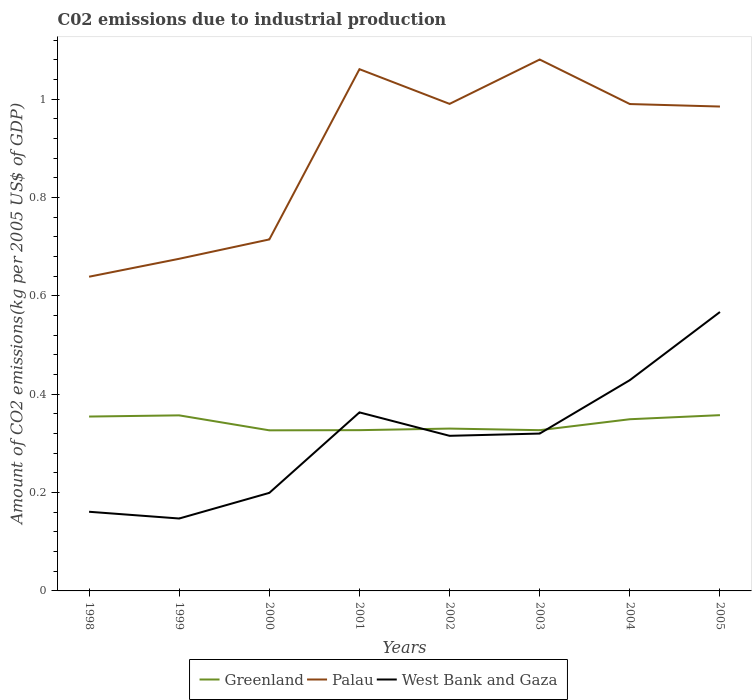Does the line corresponding to West Bank and Gaza intersect with the line corresponding to Palau?
Your response must be concise. No. Is the number of lines equal to the number of legend labels?
Keep it short and to the point. Yes. Across all years, what is the maximum amount of CO2 emitted due to industrial production in West Bank and Gaza?
Make the answer very short. 0.15. In which year was the amount of CO2 emitted due to industrial production in Greenland maximum?
Offer a very short reply. 2000. What is the total amount of CO2 emitted due to industrial production in West Bank and Gaza in the graph?
Provide a short and direct response. -0. What is the difference between the highest and the second highest amount of CO2 emitted due to industrial production in Palau?
Give a very brief answer. 0.44. How many years are there in the graph?
Provide a short and direct response. 8. Does the graph contain any zero values?
Your response must be concise. No. Does the graph contain grids?
Give a very brief answer. No. Where does the legend appear in the graph?
Ensure brevity in your answer.  Bottom center. What is the title of the graph?
Your answer should be very brief. C02 emissions due to industrial production. What is the label or title of the X-axis?
Keep it short and to the point. Years. What is the label or title of the Y-axis?
Provide a succinct answer. Amount of CO2 emissions(kg per 2005 US$ of GDP). What is the Amount of CO2 emissions(kg per 2005 US$ of GDP) of Greenland in 1998?
Make the answer very short. 0.35. What is the Amount of CO2 emissions(kg per 2005 US$ of GDP) in Palau in 1998?
Your answer should be compact. 0.64. What is the Amount of CO2 emissions(kg per 2005 US$ of GDP) in West Bank and Gaza in 1998?
Make the answer very short. 0.16. What is the Amount of CO2 emissions(kg per 2005 US$ of GDP) in Greenland in 1999?
Make the answer very short. 0.36. What is the Amount of CO2 emissions(kg per 2005 US$ of GDP) in Palau in 1999?
Offer a terse response. 0.68. What is the Amount of CO2 emissions(kg per 2005 US$ of GDP) in West Bank and Gaza in 1999?
Your answer should be very brief. 0.15. What is the Amount of CO2 emissions(kg per 2005 US$ of GDP) in Greenland in 2000?
Keep it short and to the point. 0.33. What is the Amount of CO2 emissions(kg per 2005 US$ of GDP) of Palau in 2000?
Provide a succinct answer. 0.71. What is the Amount of CO2 emissions(kg per 2005 US$ of GDP) of West Bank and Gaza in 2000?
Your answer should be very brief. 0.2. What is the Amount of CO2 emissions(kg per 2005 US$ of GDP) in Greenland in 2001?
Your answer should be very brief. 0.33. What is the Amount of CO2 emissions(kg per 2005 US$ of GDP) in Palau in 2001?
Your answer should be compact. 1.06. What is the Amount of CO2 emissions(kg per 2005 US$ of GDP) of West Bank and Gaza in 2001?
Offer a very short reply. 0.36. What is the Amount of CO2 emissions(kg per 2005 US$ of GDP) of Greenland in 2002?
Make the answer very short. 0.33. What is the Amount of CO2 emissions(kg per 2005 US$ of GDP) in Palau in 2002?
Give a very brief answer. 0.99. What is the Amount of CO2 emissions(kg per 2005 US$ of GDP) of West Bank and Gaza in 2002?
Ensure brevity in your answer.  0.32. What is the Amount of CO2 emissions(kg per 2005 US$ of GDP) in Greenland in 2003?
Your answer should be compact. 0.33. What is the Amount of CO2 emissions(kg per 2005 US$ of GDP) in Palau in 2003?
Give a very brief answer. 1.08. What is the Amount of CO2 emissions(kg per 2005 US$ of GDP) in West Bank and Gaza in 2003?
Your response must be concise. 0.32. What is the Amount of CO2 emissions(kg per 2005 US$ of GDP) of Greenland in 2004?
Your response must be concise. 0.35. What is the Amount of CO2 emissions(kg per 2005 US$ of GDP) of Palau in 2004?
Keep it short and to the point. 0.99. What is the Amount of CO2 emissions(kg per 2005 US$ of GDP) of West Bank and Gaza in 2004?
Offer a terse response. 0.43. What is the Amount of CO2 emissions(kg per 2005 US$ of GDP) in Greenland in 2005?
Your answer should be very brief. 0.36. What is the Amount of CO2 emissions(kg per 2005 US$ of GDP) of Palau in 2005?
Offer a very short reply. 0.99. What is the Amount of CO2 emissions(kg per 2005 US$ of GDP) in West Bank and Gaza in 2005?
Give a very brief answer. 0.57. Across all years, what is the maximum Amount of CO2 emissions(kg per 2005 US$ of GDP) of Greenland?
Ensure brevity in your answer.  0.36. Across all years, what is the maximum Amount of CO2 emissions(kg per 2005 US$ of GDP) of Palau?
Make the answer very short. 1.08. Across all years, what is the maximum Amount of CO2 emissions(kg per 2005 US$ of GDP) in West Bank and Gaza?
Provide a short and direct response. 0.57. Across all years, what is the minimum Amount of CO2 emissions(kg per 2005 US$ of GDP) in Greenland?
Give a very brief answer. 0.33. Across all years, what is the minimum Amount of CO2 emissions(kg per 2005 US$ of GDP) of Palau?
Keep it short and to the point. 0.64. Across all years, what is the minimum Amount of CO2 emissions(kg per 2005 US$ of GDP) in West Bank and Gaza?
Provide a short and direct response. 0.15. What is the total Amount of CO2 emissions(kg per 2005 US$ of GDP) of Greenland in the graph?
Offer a terse response. 2.73. What is the total Amount of CO2 emissions(kg per 2005 US$ of GDP) in Palau in the graph?
Provide a short and direct response. 7.14. What is the total Amount of CO2 emissions(kg per 2005 US$ of GDP) of West Bank and Gaza in the graph?
Ensure brevity in your answer.  2.5. What is the difference between the Amount of CO2 emissions(kg per 2005 US$ of GDP) in Greenland in 1998 and that in 1999?
Make the answer very short. -0. What is the difference between the Amount of CO2 emissions(kg per 2005 US$ of GDP) in Palau in 1998 and that in 1999?
Offer a terse response. -0.04. What is the difference between the Amount of CO2 emissions(kg per 2005 US$ of GDP) in West Bank and Gaza in 1998 and that in 1999?
Your response must be concise. 0.01. What is the difference between the Amount of CO2 emissions(kg per 2005 US$ of GDP) of Greenland in 1998 and that in 2000?
Your answer should be very brief. 0.03. What is the difference between the Amount of CO2 emissions(kg per 2005 US$ of GDP) in Palau in 1998 and that in 2000?
Offer a very short reply. -0.08. What is the difference between the Amount of CO2 emissions(kg per 2005 US$ of GDP) in West Bank and Gaza in 1998 and that in 2000?
Your response must be concise. -0.04. What is the difference between the Amount of CO2 emissions(kg per 2005 US$ of GDP) of Greenland in 1998 and that in 2001?
Offer a terse response. 0.03. What is the difference between the Amount of CO2 emissions(kg per 2005 US$ of GDP) in Palau in 1998 and that in 2001?
Provide a short and direct response. -0.42. What is the difference between the Amount of CO2 emissions(kg per 2005 US$ of GDP) of West Bank and Gaza in 1998 and that in 2001?
Ensure brevity in your answer.  -0.2. What is the difference between the Amount of CO2 emissions(kg per 2005 US$ of GDP) of Greenland in 1998 and that in 2002?
Offer a very short reply. 0.02. What is the difference between the Amount of CO2 emissions(kg per 2005 US$ of GDP) in Palau in 1998 and that in 2002?
Your answer should be very brief. -0.35. What is the difference between the Amount of CO2 emissions(kg per 2005 US$ of GDP) in West Bank and Gaza in 1998 and that in 2002?
Provide a short and direct response. -0.15. What is the difference between the Amount of CO2 emissions(kg per 2005 US$ of GDP) in Greenland in 1998 and that in 2003?
Your response must be concise. 0.03. What is the difference between the Amount of CO2 emissions(kg per 2005 US$ of GDP) in Palau in 1998 and that in 2003?
Your answer should be very brief. -0.44. What is the difference between the Amount of CO2 emissions(kg per 2005 US$ of GDP) of West Bank and Gaza in 1998 and that in 2003?
Offer a very short reply. -0.16. What is the difference between the Amount of CO2 emissions(kg per 2005 US$ of GDP) in Greenland in 1998 and that in 2004?
Offer a very short reply. 0.01. What is the difference between the Amount of CO2 emissions(kg per 2005 US$ of GDP) of Palau in 1998 and that in 2004?
Offer a terse response. -0.35. What is the difference between the Amount of CO2 emissions(kg per 2005 US$ of GDP) in West Bank and Gaza in 1998 and that in 2004?
Your answer should be very brief. -0.27. What is the difference between the Amount of CO2 emissions(kg per 2005 US$ of GDP) in Greenland in 1998 and that in 2005?
Provide a succinct answer. -0. What is the difference between the Amount of CO2 emissions(kg per 2005 US$ of GDP) of Palau in 1998 and that in 2005?
Provide a succinct answer. -0.35. What is the difference between the Amount of CO2 emissions(kg per 2005 US$ of GDP) in West Bank and Gaza in 1998 and that in 2005?
Keep it short and to the point. -0.41. What is the difference between the Amount of CO2 emissions(kg per 2005 US$ of GDP) of Greenland in 1999 and that in 2000?
Give a very brief answer. 0.03. What is the difference between the Amount of CO2 emissions(kg per 2005 US$ of GDP) in Palau in 1999 and that in 2000?
Your answer should be very brief. -0.04. What is the difference between the Amount of CO2 emissions(kg per 2005 US$ of GDP) in West Bank and Gaza in 1999 and that in 2000?
Offer a very short reply. -0.05. What is the difference between the Amount of CO2 emissions(kg per 2005 US$ of GDP) in Greenland in 1999 and that in 2001?
Ensure brevity in your answer.  0.03. What is the difference between the Amount of CO2 emissions(kg per 2005 US$ of GDP) in Palau in 1999 and that in 2001?
Your response must be concise. -0.39. What is the difference between the Amount of CO2 emissions(kg per 2005 US$ of GDP) in West Bank and Gaza in 1999 and that in 2001?
Provide a succinct answer. -0.22. What is the difference between the Amount of CO2 emissions(kg per 2005 US$ of GDP) in Greenland in 1999 and that in 2002?
Your response must be concise. 0.03. What is the difference between the Amount of CO2 emissions(kg per 2005 US$ of GDP) of Palau in 1999 and that in 2002?
Offer a very short reply. -0.32. What is the difference between the Amount of CO2 emissions(kg per 2005 US$ of GDP) in West Bank and Gaza in 1999 and that in 2002?
Offer a terse response. -0.17. What is the difference between the Amount of CO2 emissions(kg per 2005 US$ of GDP) in Greenland in 1999 and that in 2003?
Provide a succinct answer. 0.03. What is the difference between the Amount of CO2 emissions(kg per 2005 US$ of GDP) in Palau in 1999 and that in 2003?
Provide a succinct answer. -0.41. What is the difference between the Amount of CO2 emissions(kg per 2005 US$ of GDP) of West Bank and Gaza in 1999 and that in 2003?
Your response must be concise. -0.17. What is the difference between the Amount of CO2 emissions(kg per 2005 US$ of GDP) in Greenland in 1999 and that in 2004?
Offer a very short reply. 0.01. What is the difference between the Amount of CO2 emissions(kg per 2005 US$ of GDP) in Palau in 1999 and that in 2004?
Provide a succinct answer. -0.31. What is the difference between the Amount of CO2 emissions(kg per 2005 US$ of GDP) of West Bank and Gaza in 1999 and that in 2004?
Your response must be concise. -0.28. What is the difference between the Amount of CO2 emissions(kg per 2005 US$ of GDP) in Greenland in 1999 and that in 2005?
Keep it short and to the point. -0. What is the difference between the Amount of CO2 emissions(kg per 2005 US$ of GDP) in Palau in 1999 and that in 2005?
Provide a succinct answer. -0.31. What is the difference between the Amount of CO2 emissions(kg per 2005 US$ of GDP) of West Bank and Gaza in 1999 and that in 2005?
Give a very brief answer. -0.42. What is the difference between the Amount of CO2 emissions(kg per 2005 US$ of GDP) in Greenland in 2000 and that in 2001?
Your answer should be very brief. -0. What is the difference between the Amount of CO2 emissions(kg per 2005 US$ of GDP) of Palau in 2000 and that in 2001?
Your answer should be compact. -0.35. What is the difference between the Amount of CO2 emissions(kg per 2005 US$ of GDP) in West Bank and Gaza in 2000 and that in 2001?
Offer a terse response. -0.16. What is the difference between the Amount of CO2 emissions(kg per 2005 US$ of GDP) in Greenland in 2000 and that in 2002?
Ensure brevity in your answer.  -0. What is the difference between the Amount of CO2 emissions(kg per 2005 US$ of GDP) of Palau in 2000 and that in 2002?
Offer a very short reply. -0.28. What is the difference between the Amount of CO2 emissions(kg per 2005 US$ of GDP) in West Bank and Gaza in 2000 and that in 2002?
Offer a very short reply. -0.12. What is the difference between the Amount of CO2 emissions(kg per 2005 US$ of GDP) of Greenland in 2000 and that in 2003?
Make the answer very short. -0. What is the difference between the Amount of CO2 emissions(kg per 2005 US$ of GDP) of Palau in 2000 and that in 2003?
Ensure brevity in your answer.  -0.37. What is the difference between the Amount of CO2 emissions(kg per 2005 US$ of GDP) in West Bank and Gaza in 2000 and that in 2003?
Make the answer very short. -0.12. What is the difference between the Amount of CO2 emissions(kg per 2005 US$ of GDP) in Greenland in 2000 and that in 2004?
Provide a short and direct response. -0.02. What is the difference between the Amount of CO2 emissions(kg per 2005 US$ of GDP) of Palau in 2000 and that in 2004?
Offer a terse response. -0.28. What is the difference between the Amount of CO2 emissions(kg per 2005 US$ of GDP) of West Bank and Gaza in 2000 and that in 2004?
Your answer should be compact. -0.23. What is the difference between the Amount of CO2 emissions(kg per 2005 US$ of GDP) in Greenland in 2000 and that in 2005?
Provide a succinct answer. -0.03. What is the difference between the Amount of CO2 emissions(kg per 2005 US$ of GDP) of Palau in 2000 and that in 2005?
Offer a terse response. -0.27. What is the difference between the Amount of CO2 emissions(kg per 2005 US$ of GDP) of West Bank and Gaza in 2000 and that in 2005?
Make the answer very short. -0.37. What is the difference between the Amount of CO2 emissions(kg per 2005 US$ of GDP) in Greenland in 2001 and that in 2002?
Ensure brevity in your answer.  -0. What is the difference between the Amount of CO2 emissions(kg per 2005 US$ of GDP) of Palau in 2001 and that in 2002?
Offer a terse response. 0.07. What is the difference between the Amount of CO2 emissions(kg per 2005 US$ of GDP) of West Bank and Gaza in 2001 and that in 2002?
Offer a very short reply. 0.05. What is the difference between the Amount of CO2 emissions(kg per 2005 US$ of GDP) of Palau in 2001 and that in 2003?
Provide a short and direct response. -0.02. What is the difference between the Amount of CO2 emissions(kg per 2005 US$ of GDP) in West Bank and Gaza in 2001 and that in 2003?
Provide a succinct answer. 0.04. What is the difference between the Amount of CO2 emissions(kg per 2005 US$ of GDP) in Greenland in 2001 and that in 2004?
Your answer should be very brief. -0.02. What is the difference between the Amount of CO2 emissions(kg per 2005 US$ of GDP) in Palau in 2001 and that in 2004?
Keep it short and to the point. 0.07. What is the difference between the Amount of CO2 emissions(kg per 2005 US$ of GDP) of West Bank and Gaza in 2001 and that in 2004?
Keep it short and to the point. -0.07. What is the difference between the Amount of CO2 emissions(kg per 2005 US$ of GDP) in Greenland in 2001 and that in 2005?
Give a very brief answer. -0.03. What is the difference between the Amount of CO2 emissions(kg per 2005 US$ of GDP) of Palau in 2001 and that in 2005?
Your answer should be compact. 0.08. What is the difference between the Amount of CO2 emissions(kg per 2005 US$ of GDP) of West Bank and Gaza in 2001 and that in 2005?
Your answer should be very brief. -0.2. What is the difference between the Amount of CO2 emissions(kg per 2005 US$ of GDP) of Greenland in 2002 and that in 2003?
Your answer should be very brief. 0. What is the difference between the Amount of CO2 emissions(kg per 2005 US$ of GDP) in Palau in 2002 and that in 2003?
Your response must be concise. -0.09. What is the difference between the Amount of CO2 emissions(kg per 2005 US$ of GDP) of West Bank and Gaza in 2002 and that in 2003?
Ensure brevity in your answer.  -0. What is the difference between the Amount of CO2 emissions(kg per 2005 US$ of GDP) of Greenland in 2002 and that in 2004?
Your response must be concise. -0.02. What is the difference between the Amount of CO2 emissions(kg per 2005 US$ of GDP) in Palau in 2002 and that in 2004?
Offer a terse response. 0. What is the difference between the Amount of CO2 emissions(kg per 2005 US$ of GDP) of West Bank and Gaza in 2002 and that in 2004?
Make the answer very short. -0.11. What is the difference between the Amount of CO2 emissions(kg per 2005 US$ of GDP) in Greenland in 2002 and that in 2005?
Provide a short and direct response. -0.03. What is the difference between the Amount of CO2 emissions(kg per 2005 US$ of GDP) in Palau in 2002 and that in 2005?
Ensure brevity in your answer.  0.01. What is the difference between the Amount of CO2 emissions(kg per 2005 US$ of GDP) of West Bank and Gaza in 2002 and that in 2005?
Keep it short and to the point. -0.25. What is the difference between the Amount of CO2 emissions(kg per 2005 US$ of GDP) in Greenland in 2003 and that in 2004?
Offer a very short reply. -0.02. What is the difference between the Amount of CO2 emissions(kg per 2005 US$ of GDP) of Palau in 2003 and that in 2004?
Offer a very short reply. 0.09. What is the difference between the Amount of CO2 emissions(kg per 2005 US$ of GDP) in West Bank and Gaza in 2003 and that in 2004?
Provide a succinct answer. -0.11. What is the difference between the Amount of CO2 emissions(kg per 2005 US$ of GDP) in Greenland in 2003 and that in 2005?
Your answer should be very brief. -0.03. What is the difference between the Amount of CO2 emissions(kg per 2005 US$ of GDP) in Palau in 2003 and that in 2005?
Provide a short and direct response. 0.1. What is the difference between the Amount of CO2 emissions(kg per 2005 US$ of GDP) of West Bank and Gaza in 2003 and that in 2005?
Ensure brevity in your answer.  -0.25. What is the difference between the Amount of CO2 emissions(kg per 2005 US$ of GDP) in Greenland in 2004 and that in 2005?
Ensure brevity in your answer.  -0.01. What is the difference between the Amount of CO2 emissions(kg per 2005 US$ of GDP) in Palau in 2004 and that in 2005?
Give a very brief answer. 0.01. What is the difference between the Amount of CO2 emissions(kg per 2005 US$ of GDP) of West Bank and Gaza in 2004 and that in 2005?
Keep it short and to the point. -0.14. What is the difference between the Amount of CO2 emissions(kg per 2005 US$ of GDP) of Greenland in 1998 and the Amount of CO2 emissions(kg per 2005 US$ of GDP) of Palau in 1999?
Give a very brief answer. -0.32. What is the difference between the Amount of CO2 emissions(kg per 2005 US$ of GDP) of Greenland in 1998 and the Amount of CO2 emissions(kg per 2005 US$ of GDP) of West Bank and Gaza in 1999?
Give a very brief answer. 0.21. What is the difference between the Amount of CO2 emissions(kg per 2005 US$ of GDP) in Palau in 1998 and the Amount of CO2 emissions(kg per 2005 US$ of GDP) in West Bank and Gaza in 1999?
Offer a terse response. 0.49. What is the difference between the Amount of CO2 emissions(kg per 2005 US$ of GDP) in Greenland in 1998 and the Amount of CO2 emissions(kg per 2005 US$ of GDP) in Palau in 2000?
Your answer should be compact. -0.36. What is the difference between the Amount of CO2 emissions(kg per 2005 US$ of GDP) in Greenland in 1998 and the Amount of CO2 emissions(kg per 2005 US$ of GDP) in West Bank and Gaza in 2000?
Make the answer very short. 0.16. What is the difference between the Amount of CO2 emissions(kg per 2005 US$ of GDP) of Palau in 1998 and the Amount of CO2 emissions(kg per 2005 US$ of GDP) of West Bank and Gaza in 2000?
Your answer should be very brief. 0.44. What is the difference between the Amount of CO2 emissions(kg per 2005 US$ of GDP) of Greenland in 1998 and the Amount of CO2 emissions(kg per 2005 US$ of GDP) of Palau in 2001?
Ensure brevity in your answer.  -0.71. What is the difference between the Amount of CO2 emissions(kg per 2005 US$ of GDP) in Greenland in 1998 and the Amount of CO2 emissions(kg per 2005 US$ of GDP) in West Bank and Gaza in 2001?
Offer a very short reply. -0.01. What is the difference between the Amount of CO2 emissions(kg per 2005 US$ of GDP) in Palau in 1998 and the Amount of CO2 emissions(kg per 2005 US$ of GDP) in West Bank and Gaza in 2001?
Ensure brevity in your answer.  0.28. What is the difference between the Amount of CO2 emissions(kg per 2005 US$ of GDP) in Greenland in 1998 and the Amount of CO2 emissions(kg per 2005 US$ of GDP) in Palau in 2002?
Make the answer very short. -0.64. What is the difference between the Amount of CO2 emissions(kg per 2005 US$ of GDP) of Greenland in 1998 and the Amount of CO2 emissions(kg per 2005 US$ of GDP) of West Bank and Gaza in 2002?
Provide a short and direct response. 0.04. What is the difference between the Amount of CO2 emissions(kg per 2005 US$ of GDP) in Palau in 1998 and the Amount of CO2 emissions(kg per 2005 US$ of GDP) in West Bank and Gaza in 2002?
Your answer should be compact. 0.32. What is the difference between the Amount of CO2 emissions(kg per 2005 US$ of GDP) of Greenland in 1998 and the Amount of CO2 emissions(kg per 2005 US$ of GDP) of Palau in 2003?
Give a very brief answer. -0.73. What is the difference between the Amount of CO2 emissions(kg per 2005 US$ of GDP) of Greenland in 1998 and the Amount of CO2 emissions(kg per 2005 US$ of GDP) of West Bank and Gaza in 2003?
Provide a succinct answer. 0.03. What is the difference between the Amount of CO2 emissions(kg per 2005 US$ of GDP) in Palau in 1998 and the Amount of CO2 emissions(kg per 2005 US$ of GDP) in West Bank and Gaza in 2003?
Your answer should be compact. 0.32. What is the difference between the Amount of CO2 emissions(kg per 2005 US$ of GDP) of Greenland in 1998 and the Amount of CO2 emissions(kg per 2005 US$ of GDP) of Palau in 2004?
Offer a very short reply. -0.64. What is the difference between the Amount of CO2 emissions(kg per 2005 US$ of GDP) of Greenland in 1998 and the Amount of CO2 emissions(kg per 2005 US$ of GDP) of West Bank and Gaza in 2004?
Ensure brevity in your answer.  -0.07. What is the difference between the Amount of CO2 emissions(kg per 2005 US$ of GDP) of Palau in 1998 and the Amount of CO2 emissions(kg per 2005 US$ of GDP) of West Bank and Gaza in 2004?
Your response must be concise. 0.21. What is the difference between the Amount of CO2 emissions(kg per 2005 US$ of GDP) of Greenland in 1998 and the Amount of CO2 emissions(kg per 2005 US$ of GDP) of Palau in 2005?
Give a very brief answer. -0.63. What is the difference between the Amount of CO2 emissions(kg per 2005 US$ of GDP) in Greenland in 1998 and the Amount of CO2 emissions(kg per 2005 US$ of GDP) in West Bank and Gaza in 2005?
Offer a terse response. -0.21. What is the difference between the Amount of CO2 emissions(kg per 2005 US$ of GDP) of Palau in 1998 and the Amount of CO2 emissions(kg per 2005 US$ of GDP) of West Bank and Gaza in 2005?
Your answer should be compact. 0.07. What is the difference between the Amount of CO2 emissions(kg per 2005 US$ of GDP) of Greenland in 1999 and the Amount of CO2 emissions(kg per 2005 US$ of GDP) of Palau in 2000?
Your answer should be very brief. -0.36. What is the difference between the Amount of CO2 emissions(kg per 2005 US$ of GDP) of Greenland in 1999 and the Amount of CO2 emissions(kg per 2005 US$ of GDP) of West Bank and Gaza in 2000?
Provide a short and direct response. 0.16. What is the difference between the Amount of CO2 emissions(kg per 2005 US$ of GDP) of Palau in 1999 and the Amount of CO2 emissions(kg per 2005 US$ of GDP) of West Bank and Gaza in 2000?
Your answer should be compact. 0.48. What is the difference between the Amount of CO2 emissions(kg per 2005 US$ of GDP) in Greenland in 1999 and the Amount of CO2 emissions(kg per 2005 US$ of GDP) in Palau in 2001?
Make the answer very short. -0.7. What is the difference between the Amount of CO2 emissions(kg per 2005 US$ of GDP) in Greenland in 1999 and the Amount of CO2 emissions(kg per 2005 US$ of GDP) in West Bank and Gaza in 2001?
Your answer should be very brief. -0.01. What is the difference between the Amount of CO2 emissions(kg per 2005 US$ of GDP) in Palau in 1999 and the Amount of CO2 emissions(kg per 2005 US$ of GDP) in West Bank and Gaza in 2001?
Provide a short and direct response. 0.31. What is the difference between the Amount of CO2 emissions(kg per 2005 US$ of GDP) in Greenland in 1999 and the Amount of CO2 emissions(kg per 2005 US$ of GDP) in Palau in 2002?
Provide a succinct answer. -0.63. What is the difference between the Amount of CO2 emissions(kg per 2005 US$ of GDP) of Greenland in 1999 and the Amount of CO2 emissions(kg per 2005 US$ of GDP) of West Bank and Gaza in 2002?
Ensure brevity in your answer.  0.04. What is the difference between the Amount of CO2 emissions(kg per 2005 US$ of GDP) in Palau in 1999 and the Amount of CO2 emissions(kg per 2005 US$ of GDP) in West Bank and Gaza in 2002?
Provide a short and direct response. 0.36. What is the difference between the Amount of CO2 emissions(kg per 2005 US$ of GDP) of Greenland in 1999 and the Amount of CO2 emissions(kg per 2005 US$ of GDP) of Palau in 2003?
Offer a terse response. -0.72. What is the difference between the Amount of CO2 emissions(kg per 2005 US$ of GDP) of Greenland in 1999 and the Amount of CO2 emissions(kg per 2005 US$ of GDP) of West Bank and Gaza in 2003?
Provide a short and direct response. 0.04. What is the difference between the Amount of CO2 emissions(kg per 2005 US$ of GDP) in Palau in 1999 and the Amount of CO2 emissions(kg per 2005 US$ of GDP) in West Bank and Gaza in 2003?
Your response must be concise. 0.36. What is the difference between the Amount of CO2 emissions(kg per 2005 US$ of GDP) in Greenland in 1999 and the Amount of CO2 emissions(kg per 2005 US$ of GDP) in Palau in 2004?
Your answer should be compact. -0.63. What is the difference between the Amount of CO2 emissions(kg per 2005 US$ of GDP) of Greenland in 1999 and the Amount of CO2 emissions(kg per 2005 US$ of GDP) of West Bank and Gaza in 2004?
Your response must be concise. -0.07. What is the difference between the Amount of CO2 emissions(kg per 2005 US$ of GDP) of Palau in 1999 and the Amount of CO2 emissions(kg per 2005 US$ of GDP) of West Bank and Gaza in 2004?
Give a very brief answer. 0.25. What is the difference between the Amount of CO2 emissions(kg per 2005 US$ of GDP) in Greenland in 1999 and the Amount of CO2 emissions(kg per 2005 US$ of GDP) in Palau in 2005?
Make the answer very short. -0.63. What is the difference between the Amount of CO2 emissions(kg per 2005 US$ of GDP) in Greenland in 1999 and the Amount of CO2 emissions(kg per 2005 US$ of GDP) in West Bank and Gaza in 2005?
Provide a succinct answer. -0.21. What is the difference between the Amount of CO2 emissions(kg per 2005 US$ of GDP) in Palau in 1999 and the Amount of CO2 emissions(kg per 2005 US$ of GDP) in West Bank and Gaza in 2005?
Provide a succinct answer. 0.11. What is the difference between the Amount of CO2 emissions(kg per 2005 US$ of GDP) of Greenland in 2000 and the Amount of CO2 emissions(kg per 2005 US$ of GDP) of Palau in 2001?
Ensure brevity in your answer.  -0.73. What is the difference between the Amount of CO2 emissions(kg per 2005 US$ of GDP) of Greenland in 2000 and the Amount of CO2 emissions(kg per 2005 US$ of GDP) of West Bank and Gaza in 2001?
Keep it short and to the point. -0.04. What is the difference between the Amount of CO2 emissions(kg per 2005 US$ of GDP) of Palau in 2000 and the Amount of CO2 emissions(kg per 2005 US$ of GDP) of West Bank and Gaza in 2001?
Ensure brevity in your answer.  0.35. What is the difference between the Amount of CO2 emissions(kg per 2005 US$ of GDP) in Greenland in 2000 and the Amount of CO2 emissions(kg per 2005 US$ of GDP) in Palau in 2002?
Provide a short and direct response. -0.66. What is the difference between the Amount of CO2 emissions(kg per 2005 US$ of GDP) in Greenland in 2000 and the Amount of CO2 emissions(kg per 2005 US$ of GDP) in West Bank and Gaza in 2002?
Make the answer very short. 0.01. What is the difference between the Amount of CO2 emissions(kg per 2005 US$ of GDP) in Palau in 2000 and the Amount of CO2 emissions(kg per 2005 US$ of GDP) in West Bank and Gaza in 2002?
Your answer should be very brief. 0.4. What is the difference between the Amount of CO2 emissions(kg per 2005 US$ of GDP) in Greenland in 2000 and the Amount of CO2 emissions(kg per 2005 US$ of GDP) in Palau in 2003?
Your response must be concise. -0.75. What is the difference between the Amount of CO2 emissions(kg per 2005 US$ of GDP) of Greenland in 2000 and the Amount of CO2 emissions(kg per 2005 US$ of GDP) of West Bank and Gaza in 2003?
Make the answer very short. 0.01. What is the difference between the Amount of CO2 emissions(kg per 2005 US$ of GDP) of Palau in 2000 and the Amount of CO2 emissions(kg per 2005 US$ of GDP) of West Bank and Gaza in 2003?
Offer a terse response. 0.39. What is the difference between the Amount of CO2 emissions(kg per 2005 US$ of GDP) of Greenland in 2000 and the Amount of CO2 emissions(kg per 2005 US$ of GDP) of Palau in 2004?
Provide a succinct answer. -0.66. What is the difference between the Amount of CO2 emissions(kg per 2005 US$ of GDP) of Greenland in 2000 and the Amount of CO2 emissions(kg per 2005 US$ of GDP) of West Bank and Gaza in 2004?
Provide a succinct answer. -0.1. What is the difference between the Amount of CO2 emissions(kg per 2005 US$ of GDP) of Palau in 2000 and the Amount of CO2 emissions(kg per 2005 US$ of GDP) of West Bank and Gaza in 2004?
Your answer should be very brief. 0.29. What is the difference between the Amount of CO2 emissions(kg per 2005 US$ of GDP) in Greenland in 2000 and the Amount of CO2 emissions(kg per 2005 US$ of GDP) in Palau in 2005?
Your response must be concise. -0.66. What is the difference between the Amount of CO2 emissions(kg per 2005 US$ of GDP) of Greenland in 2000 and the Amount of CO2 emissions(kg per 2005 US$ of GDP) of West Bank and Gaza in 2005?
Keep it short and to the point. -0.24. What is the difference between the Amount of CO2 emissions(kg per 2005 US$ of GDP) in Palau in 2000 and the Amount of CO2 emissions(kg per 2005 US$ of GDP) in West Bank and Gaza in 2005?
Your answer should be compact. 0.15. What is the difference between the Amount of CO2 emissions(kg per 2005 US$ of GDP) of Greenland in 2001 and the Amount of CO2 emissions(kg per 2005 US$ of GDP) of Palau in 2002?
Offer a terse response. -0.66. What is the difference between the Amount of CO2 emissions(kg per 2005 US$ of GDP) of Greenland in 2001 and the Amount of CO2 emissions(kg per 2005 US$ of GDP) of West Bank and Gaza in 2002?
Your response must be concise. 0.01. What is the difference between the Amount of CO2 emissions(kg per 2005 US$ of GDP) in Palau in 2001 and the Amount of CO2 emissions(kg per 2005 US$ of GDP) in West Bank and Gaza in 2002?
Make the answer very short. 0.75. What is the difference between the Amount of CO2 emissions(kg per 2005 US$ of GDP) in Greenland in 2001 and the Amount of CO2 emissions(kg per 2005 US$ of GDP) in Palau in 2003?
Provide a short and direct response. -0.75. What is the difference between the Amount of CO2 emissions(kg per 2005 US$ of GDP) of Greenland in 2001 and the Amount of CO2 emissions(kg per 2005 US$ of GDP) of West Bank and Gaza in 2003?
Make the answer very short. 0.01. What is the difference between the Amount of CO2 emissions(kg per 2005 US$ of GDP) of Palau in 2001 and the Amount of CO2 emissions(kg per 2005 US$ of GDP) of West Bank and Gaza in 2003?
Keep it short and to the point. 0.74. What is the difference between the Amount of CO2 emissions(kg per 2005 US$ of GDP) of Greenland in 2001 and the Amount of CO2 emissions(kg per 2005 US$ of GDP) of Palau in 2004?
Provide a succinct answer. -0.66. What is the difference between the Amount of CO2 emissions(kg per 2005 US$ of GDP) of Greenland in 2001 and the Amount of CO2 emissions(kg per 2005 US$ of GDP) of West Bank and Gaza in 2004?
Make the answer very short. -0.1. What is the difference between the Amount of CO2 emissions(kg per 2005 US$ of GDP) of Palau in 2001 and the Amount of CO2 emissions(kg per 2005 US$ of GDP) of West Bank and Gaza in 2004?
Ensure brevity in your answer.  0.63. What is the difference between the Amount of CO2 emissions(kg per 2005 US$ of GDP) in Greenland in 2001 and the Amount of CO2 emissions(kg per 2005 US$ of GDP) in Palau in 2005?
Ensure brevity in your answer.  -0.66. What is the difference between the Amount of CO2 emissions(kg per 2005 US$ of GDP) of Greenland in 2001 and the Amount of CO2 emissions(kg per 2005 US$ of GDP) of West Bank and Gaza in 2005?
Your answer should be very brief. -0.24. What is the difference between the Amount of CO2 emissions(kg per 2005 US$ of GDP) of Palau in 2001 and the Amount of CO2 emissions(kg per 2005 US$ of GDP) of West Bank and Gaza in 2005?
Your response must be concise. 0.49. What is the difference between the Amount of CO2 emissions(kg per 2005 US$ of GDP) of Greenland in 2002 and the Amount of CO2 emissions(kg per 2005 US$ of GDP) of Palau in 2003?
Make the answer very short. -0.75. What is the difference between the Amount of CO2 emissions(kg per 2005 US$ of GDP) of Greenland in 2002 and the Amount of CO2 emissions(kg per 2005 US$ of GDP) of West Bank and Gaza in 2003?
Provide a short and direct response. 0.01. What is the difference between the Amount of CO2 emissions(kg per 2005 US$ of GDP) of Palau in 2002 and the Amount of CO2 emissions(kg per 2005 US$ of GDP) of West Bank and Gaza in 2003?
Your answer should be compact. 0.67. What is the difference between the Amount of CO2 emissions(kg per 2005 US$ of GDP) in Greenland in 2002 and the Amount of CO2 emissions(kg per 2005 US$ of GDP) in Palau in 2004?
Provide a short and direct response. -0.66. What is the difference between the Amount of CO2 emissions(kg per 2005 US$ of GDP) of Greenland in 2002 and the Amount of CO2 emissions(kg per 2005 US$ of GDP) of West Bank and Gaza in 2004?
Your response must be concise. -0.1. What is the difference between the Amount of CO2 emissions(kg per 2005 US$ of GDP) in Palau in 2002 and the Amount of CO2 emissions(kg per 2005 US$ of GDP) in West Bank and Gaza in 2004?
Offer a very short reply. 0.56. What is the difference between the Amount of CO2 emissions(kg per 2005 US$ of GDP) of Greenland in 2002 and the Amount of CO2 emissions(kg per 2005 US$ of GDP) of Palau in 2005?
Your answer should be compact. -0.66. What is the difference between the Amount of CO2 emissions(kg per 2005 US$ of GDP) of Greenland in 2002 and the Amount of CO2 emissions(kg per 2005 US$ of GDP) of West Bank and Gaza in 2005?
Your answer should be compact. -0.24. What is the difference between the Amount of CO2 emissions(kg per 2005 US$ of GDP) in Palau in 2002 and the Amount of CO2 emissions(kg per 2005 US$ of GDP) in West Bank and Gaza in 2005?
Your answer should be very brief. 0.42. What is the difference between the Amount of CO2 emissions(kg per 2005 US$ of GDP) of Greenland in 2003 and the Amount of CO2 emissions(kg per 2005 US$ of GDP) of Palau in 2004?
Offer a very short reply. -0.66. What is the difference between the Amount of CO2 emissions(kg per 2005 US$ of GDP) of Greenland in 2003 and the Amount of CO2 emissions(kg per 2005 US$ of GDP) of West Bank and Gaza in 2004?
Your answer should be very brief. -0.1. What is the difference between the Amount of CO2 emissions(kg per 2005 US$ of GDP) of Palau in 2003 and the Amount of CO2 emissions(kg per 2005 US$ of GDP) of West Bank and Gaza in 2004?
Offer a very short reply. 0.65. What is the difference between the Amount of CO2 emissions(kg per 2005 US$ of GDP) of Greenland in 2003 and the Amount of CO2 emissions(kg per 2005 US$ of GDP) of Palau in 2005?
Ensure brevity in your answer.  -0.66. What is the difference between the Amount of CO2 emissions(kg per 2005 US$ of GDP) in Greenland in 2003 and the Amount of CO2 emissions(kg per 2005 US$ of GDP) in West Bank and Gaza in 2005?
Offer a very short reply. -0.24. What is the difference between the Amount of CO2 emissions(kg per 2005 US$ of GDP) in Palau in 2003 and the Amount of CO2 emissions(kg per 2005 US$ of GDP) in West Bank and Gaza in 2005?
Give a very brief answer. 0.51. What is the difference between the Amount of CO2 emissions(kg per 2005 US$ of GDP) in Greenland in 2004 and the Amount of CO2 emissions(kg per 2005 US$ of GDP) in Palau in 2005?
Keep it short and to the point. -0.64. What is the difference between the Amount of CO2 emissions(kg per 2005 US$ of GDP) in Greenland in 2004 and the Amount of CO2 emissions(kg per 2005 US$ of GDP) in West Bank and Gaza in 2005?
Give a very brief answer. -0.22. What is the difference between the Amount of CO2 emissions(kg per 2005 US$ of GDP) in Palau in 2004 and the Amount of CO2 emissions(kg per 2005 US$ of GDP) in West Bank and Gaza in 2005?
Your answer should be compact. 0.42. What is the average Amount of CO2 emissions(kg per 2005 US$ of GDP) in Greenland per year?
Keep it short and to the point. 0.34. What is the average Amount of CO2 emissions(kg per 2005 US$ of GDP) in Palau per year?
Offer a very short reply. 0.89. What is the average Amount of CO2 emissions(kg per 2005 US$ of GDP) of West Bank and Gaza per year?
Give a very brief answer. 0.31. In the year 1998, what is the difference between the Amount of CO2 emissions(kg per 2005 US$ of GDP) in Greenland and Amount of CO2 emissions(kg per 2005 US$ of GDP) in Palau?
Offer a terse response. -0.28. In the year 1998, what is the difference between the Amount of CO2 emissions(kg per 2005 US$ of GDP) of Greenland and Amount of CO2 emissions(kg per 2005 US$ of GDP) of West Bank and Gaza?
Keep it short and to the point. 0.19. In the year 1998, what is the difference between the Amount of CO2 emissions(kg per 2005 US$ of GDP) of Palau and Amount of CO2 emissions(kg per 2005 US$ of GDP) of West Bank and Gaza?
Offer a very short reply. 0.48. In the year 1999, what is the difference between the Amount of CO2 emissions(kg per 2005 US$ of GDP) of Greenland and Amount of CO2 emissions(kg per 2005 US$ of GDP) of Palau?
Make the answer very short. -0.32. In the year 1999, what is the difference between the Amount of CO2 emissions(kg per 2005 US$ of GDP) in Greenland and Amount of CO2 emissions(kg per 2005 US$ of GDP) in West Bank and Gaza?
Offer a very short reply. 0.21. In the year 1999, what is the difference between the Amount of CO2 emissions(kg per 2005 US$ of GDP) in Palau and Amount of CO2 emissions(kg per 2005 US$ of GDP) in West Bank and Gaza?
Ensure brevity in your answer.  0.53. In the year 2000, what is the difference between the Amount of CO2 emissions(kg per 2005 US$ of GDP) in Greenland and Amount of CO2 emissions(kg per 2005 US$ of GDP) in Palau?
Your response must be concise. -0.39. In the year 2000, what is the difference between the Amount of CO2 emissions(kg per 2005 US$ of GDP) in Greenland and Amount of CO2 emissions(kg per 2005 US$ of GDP) in West Bank and Gaza?
Make the answer very short. 0.13. In the year 2000, what is the difference between the Amount of CO2 emissions(kg per 2005 US$ of GDP) in Palau and Amount of CO2 emissions(kg per 2005 US$ of GDP) in West Bank and Gaza?
Your answer should be very brief. 0.52. In the year 2001, what is the difference between the Amount of CO2 emissions(kg per 2005 US$ of GDP) in Greenland and Amount of CO2 emissions(kg per 2005 US$ of GDP) in Palau?
Your response must be concise. -0.73. In the year 2001, what is the difference between the Amount of CO2 emissions(kg per 2005 US$ of GDP) of Greenland and Amount of CO2 emissions(kg per 2005 US$ of GDP) of West Bank and Gaza?
Provide a succinct answer. -0.04. In the year 2001, what is the difference between the Amount of CO2 emissions(kg per 2005 US$ of GDP) in Palau and Amount of CO2 emissions(kg per 2005 US$ of GDP) in West Bank and Gaza?
Keep it short and to the point. 0.7. In the year 2002, what is the difference between the Amount of CO2 emissions(kg per 2005 US$ of GDP) in Greenland and Amount of CO2 emissions(kg per 2005 US$ of GDP) in Palau?
Make the answer very short. -0.66. In the year 2002, what is the difference between the Amount of CO2 emissions(kg per 2005 US$ of GDP) in Greenland and Amount of CO2 emissions(kg per 2005 US$ of GDP) in West Bank and Gaza?
Keep it short and to the point. 0.01. In the year 2002, what is the difference between the Amount of CO2 emissions(kg per 2005 US$ of GDP) in Palau and Amount of CO2 emissions(kg per 2005 US$ of GDP) in West Bank and Gaza?
Keep it short and to the point. 0.68. In the year 2003, what is the difference between the Amount of CO2 emissions(kg per 2005 US$ of GDP) of Greenland and Amount of CO2 emissions(kg per 2005 US$ of GDP) of Palau?
Ensure brevity in your answer.  -0.75. In the year 2003, what is the difference between the Amount of CO2 emissions(kg per 2005 US$ of GDP) in Greenland and Amount of CO2 emissions(kg per 2005 US$ of GDP) in West Bank and Gaza?
Your answer should be compact. 0.01. In the year 2003, what is the difference between the Amount of CO2 emissions(kg per 2005 US$ of GDP) of Palau and Amount of CO2 emissions(kg per 2005 US$ of GDP) of West Bank and Gaza?
Ensure brevity in your answer.  0.76. In the year 2004, what is the difference between the Amount of CO2 emissions(kg per 2005 US$ of GDP) of Greenland and Amount of CO2 emissions(kg per 2005 US$ of GDP) of Palau?
Offer a very short reply. -0.64. In the year 2004, what is the difference between the Amount of CO2 emissions(kg per 2005 US$ of GDP) in Greenland and Amount of CO2 emissions(kg per 2005 US$ of GDP) in West Bank and Gaza?
Your answer should be very brief. -0.08. In the year 2004, what is the difference between the Amount of CO2 emissions(kg per 2005 US$ of GDP) of Palau and Amount of CO2 emissions(kg per 2005 US$ of GDP) of West Bank and Gaza?
Keep it short and to the point. 0.56. In the year 2005, what is the difference between the Amount of CO2 emissions(kg per 2005 US$ of GDP) in Greenland and Amount of CO2 emissions(kg per 2005 US$ of GDP) in Palau?
Offer a terse response. -0.63. In the year 2005, what is the difference between the Amount of CO2 emissions(kg per 2005 US$ of GDP) in Greenland and Amount of CO2 emissions(kg per 2005 US$ of GDP) in West Bank and Gaza?
Provide a succinct answer. -0.21. In the year 2005, what is the difference between the Amount of CO2 emissions(kg per 2005 US$ of GDP) in Palau and Amount of CO2 emissions(kg per 2005 US$ of GDP) in West Bank and Gaza?
Provide a succinct answer. 0.42. What is the ratio of the Amount of CO2 emissions(kg per 2005 US$ of GDP) of Greenland in 1998 to that in 1999?
Offer a very short reply. 0.99. What is the ratio of the Amount of CO2 emissions(kg per 2005 US$ of GDP) in Palau in 1998 to that in 1999?
Ensure brevity in your answer.  0.95. What is the ratio of the Amount of CO2 emissions(kg per 2005 US$ of GDP) of West Bank and Gaza in 1998 to that in 1999?
Give a very brief answer. 1.09. What is the ratio of the Amount of CO2 emissions(kg per 2005 US$ of GDP) in Greenland in 1998 to that in 2000?
Make the answer very short. 1.09. What is the ratio of the Amount of CO2 emissions(kg per 2005 US$ of GDP) in Palau in 1998 to that in 2000?
Offer a very short reply. 0.89. What is the ratio of the Amount of CO2 emissions(kg per 2005 US$ of GDP) in West Bank and Gaza in 1998 to that in 2000?
Ensure brevity in your answer.  0.81. What is the ratio of the Amount of CO2 emissions(kg per 2005 US$ of GDP) of Greenland in 1998 to that in 2001?
Your answer should be compact. 1.08. What is the ratio of the Amount of CO2 emissions(kg per 2005 US$ of GDP) in Palau in 1998 to that in 2001?
Ensure brevity in your answer.  0.6. What is the ratio of the Amount of CO2 emissions(kg per 2005 US$ of GDP) in West Bank and Gaza in 1998 to that in 2001?
Offer a very short reply. 0.44. What is the ratio of the Amount of CO2 emissions(kg per 2005 US$ of GDP) in Greenland in 1998 to that in 2002?
Offer a very short reply. 1.07. What is the ratio of the Amount of CO2 emissions(kg per 2005 US$ of GDP) of Palau in 1998 to that in 2002?
Offer a very short reply. 0.65. What is the ratio of the Amount of CO2 emissions(kg per 2005 US$ of GDP) in West Bank and Gaza in 1998 to that in 2002?
Make the answer very short. 0.51. What is the ratio of the Amount of CO2 emissions(kg per 2005 US$ of GDP) of Greenland in 1998 to that in 2003?
Offer a terse response. 1.08. What is the ratio of the Amount of CO2 emissions(kg per 2005 US$ of GDP) in Palau in 1998 to that in 2003?
Provide a short and direct response. 0.59. What is the ratio of the Amount of CO2 emissions(kg per 2005 US$ of GDP) of West Bank and Gaza in 1998 to that in 2003?
Make the answer very short. 0.5. What is the ratio of the Amount of CO2 emissions(kg per 2005 US$ of GDP) of Greenland in 1998 to that in 2004?
Provide a short and direct response. 1.02. What is the ratio of the Amount of CO2 emissions(kg per 2005 US$ of GDP) in Palau in 1998 to that in 2004?
Ensure brevity in your answer.  0.65. What is the ratio of the Amount of CO2 emissions(kg per 2005 US$ of GDP) of West Bank and Gaza in 1998 to that in 2004?
Your answer should be compact. 0.38. What is the ratio of the Amount of CO2 emissions(kg per 2005 US$ of GDP) in Greenland in 1998 to that in 2005?
Provide a succinct answer. 0.99. What is the ratio of the Amount of CO2 emissions(kg per 2005 US$ of GDP) in Palau in 1998 to that in 2005?
Offer a very short reply. 0.65. What is the ratio of the Amount of CO2 emissions(kg per 2005 US$ of GDP) of West Bank and Gaza in 1998 to that in 2005?
Offer a very short reply. 0.28. What is the ratio of the Amount of CO2 emissions(kg per 2005 US$ of GDP) of Greenland in 1999 to that in 2000?
Offer a very short reply. 1.09. What is the ratio of the Amount of CO2 emissions(kg per 2005 US$ of GDP) of Palau in 1999 to that in 2000?
Give a very brief answer. 0.94. What is the ratio of the Amount of CO2 emissions(kg per 2005 US$ of GDP) in West Bank and Gaza in 1999 to that in 2000?
Give a very brief answer. 0.74. What is the ratio of the Amount of CO2 emissions(kg per 2005 US$ of GDP) of Greenland in 1999 to that in 2001?
Provide a short and direct response. 1.09. What is the ratio of the Amount of CO2 emissions(kg per 2005 US$ of GDP) in Palau in 1999 to that in 2001?
Your response must be concise. 0.64. What is the ratio of the Amount of CO2 emissions(kg per 2005 US$ of GDP) of West Bank and Gaza in 1999 to that in 2001?
Keep it short and to the point. 0.41. What is the ratio of the Amount of CO2 emissions(kg per 2005 US$ of GDP) in Greenland in 1999 to that in 2002?
Offer a terse response. 1.08. What is the ratio of the Amount of CO2 emissions(kg per 2005 US$ of GDP) of Palau in 1999 to that in 2002?
Your response must be concise. 0.68. What is the ratio of the Amount of CO2 emissions(kg per 2005 US$ of GDP) in West Bank and Gaza in 1999 to that in 2002?
Offer a terse response. 0.47. What is the ratio of the Amount of CO2 emissions(kg per 2005 US$ of GDP) in Greenland in 1999 to that in 2003?
Make the answer very short. 1.09. What is the ratio of the Amount of CO2 emissions(kg per 2005 US$ of GDP) in West Bank and Gaza in 1999 to that in 2003?
Give a very brief answer. 0.46. What is the ratio of the Amount of CO2 emissions(kg per 2005 US$ of GDP) of Greenland in 1999 to that in 2004?
Give a very brief answer. 1.02. What is the ratio of the Amount of CO2 emissions(kg per 2005 US$ of GDP) in Palau in 1999 to that in 2004?
Keep it short and to the point. 0.68. What is the ratio of the Amount of CO2 emissions(kg per 2005 US$ of GDP) of West Bank and Gaza in 1999 to that in 2004?
Your answer should be compact. 0.34. What is the ratio of the Amount of CO2 emissions(kg per 2005 US$ of GDP) in Palau in 1999 to that in 2005?
Provide a short and direct response. 0.69. What is the ratio of the Amount of CO2 emissions(kg per 2005 US$ of GDP) of West Bank and Gaza in 1999 to that in 2005?
Your answer should be compact. 0.26. What is the ratio of the Amount of CO2 emissions(kg per 2005 US$ of GDP) in Greenland in 2000 to that in 2001?
Ensure brevity in your answer.  1. What is the ratio of the Amount of CO2 emissions(kg per 2005 US$ of GDP) of Palau in 2000 to that in 2001?
Your response must be concise. 0.67. What is the ratio of the Amount of CO2 emissions(kg per 2005 US$ of GDP) in West Bank and Gaza in 2000 to that in 2001?
Your response must be concise. 0.55. What is the ratio of the Amount of CO2 emissions(kg per 2005 US$ of GDP) of Palau in 2000 to that in 2002?
Ensure brevity in your answer.  0.72. What is the ratio of the Amount of CO2 emissions(kg per 2005 US$ of GDP) in West Bank and Gaza in 2000 to that in 2002?
Ensure brevity in your answer.  0.63. What is the ratio of the Amount of CO2 emissions(kg per 2005 US$ of GDP) in Palau in 2000 to that in 2003?
Your answer should be very brief. 0.66. What is the ratio of the Amount of CO2 emissions(kg per 2005 US$ of GDP) of West Bank and Gaza in 2000 to that in 2003?
Offer a very short reply. 0.62. What is the ratio of the Amount of CO2 emissions(kg per 2005 US$ of GDP) in Greenland in 2000 to that in 2004?
Ensure brevity in your answer.  0.94. What is the ratio of the Amount of CO2 emissions(kg per 2005 US$ of GDP) of Palau in 2000 to that in 2004?
Make the answer very short. 0.72. What is the ratio of the Amount of CO2 emissions(kg per 2005 US$ of GDP) of West Bank and Gaza in 2000 to that in 2004?
Make the answer very short. 0.47. What is the ratio of the Amount of CO2 emissions(kg per 2005 US$ of GDP) in Greenland in 2000 to that in 2005?
Your answer should be compact. 0.91. What is the ratio of the Amount of CO2 emissions(kg per 2005 US$ of GDP) in Palau in 2000 to that in 2005?
Your response must be concise. 0.73. What is the ratio of the Amount of CO2 emissions(kg per 2005 US$ of GDP) of West Bank and Gaza in 2000 to that in 2005?
Provide a short and direct response. 0.35. What is the ratio of the Amount of CO2 emissions(kg per 2005 US$ of GDP) of Greenland in 2001 to that in 2002?
Ensure brevity in your answer.  0.99. What is the ratio of the Amount of CO2 emissions(kg per 2005 US$ of GDP) in Palau in 2001 to that in 2002?
Provide a short and direct response. 1.07. What is the ratio of the Amount of CO2 emissions(kg per 2005 US$ of GDP) of West Bank and Gaza in 2001 to that in 2002?
Ensure brevity in your answer.  1.15. What is the ratio of the Amount of CO2 emissions(kg per 2005 US$ of GDP) of Palau in 2001 to that in 2003?
Offer a terse response. 0.98. What is the ratio of the Amount of CO2 emissions(kg per 2005 US$ of GDP) in West Bank and Gaza in 2001 to that in 2003?
Your answer should be very brief. 1.13. What is the ratio of the Amount of CO2 emissions(kg per 2005 US$ of GDP) of Greenland in 2001 to that in 2004?
Provide a succinct answer. 0.94. What is the ratio of the Amount of CO2 emissions(kg per 2005 US$ of GDP) of Palau in 2001 to that in 2004?
Keep it short and to the point. 1.07. What is the ratio of the Amount of CO2 emissions(kg per 2005 US$ of GDP) of West Bank and Gaza in 2001 to that in 2004?
Your answer should be very brief. 0.85. What is the ratio of the Amount of CO2 emissions(kg per 2005 US$ of GDP) in Greenland in 2001 to that in 2005?
Your answer should be compact. 0.91. What is the ratio of the Amount of CO2 emissions(kg per 2005 US$ of GDP) in Palau in 2001 to that in 2005?
Give a very brief answer. 1.08. What is the ratio of the Amount of CO2 emissions(kg per 2005 US$ of GDP) of West Bank and Gaza in 2001 to that in 2005?
Your answer should be compact. 0.64. What is the ratio of the Amount of CO2 emissions(kg per 2005 US$ of GDP) of Greenland in 2002 to that in 2003?
Your answer should be very brief. 1.01. What is the ratio of the Amount of CO2 emissions(kg per 2005 US$ of GDP) in Palau in 2002 to that in 2003?
Give a very brief answer. 0.92. What is the ratio of the Amount of CO2 emissions(kg per 2005 US$ of GDP) of West Bank and Gaza in 2002 to that in 2003?
Offer a terse response. 0.99. What is the ratio of the Amount of CO2 emissions(kg per 2005 US$ of GDP) of Greenland in 2002 to that in 2004?
Give a very brief answer. 0.95. What is the ratio of the Amount of CO2 emissions(kg per 2005 US$ of GDP) in Palau in 2002 to that in 2004?
Offer a very short reply. 1. What is the ratio of the Amount of CO2 emissions(kg per 2005 US$ of GDP) of West Bank and Gaza in 2002 to that in 2004?
Provide a short and direct response. 0.74. What is the ratio of the Amount of CO2 emissions(kg per 2005 US$ of GDP) in Greenland in 2002 to that in 2005?
Provide a short and direct response. 0.92. What is the ratio of the Amount of CO2 emissions(kg per 2005 US$ of GDP) of West Bank and Gaza in 2002 to that in 2005?
Offer a terse response. 0.56. What is the ratio of the Amount of CO2 emissions(kg per 2005 US$ of GDP) in Greenland in 2003 to that in 2004?
Ensure brevity in your answer.  0.94. What is the ratio of the Amount of CO2 emissions(kg per 2005 US$ of GDP) in Palau in 2003 to that in 2004?
Offer a very short reply. 1.09. What is the ratio of the Amount of CO2 emissions(kg per 2005 US$ of GDP) in West Bank and Gaza in 2003 to that in 2004?
Your answer should be compact. 0.75. What is the ratio of the Amount of CO2 emissions(kg per 2005 US$ of GDP) in Greenland in 2003 to that in 2005?
Your answer should be compact. 0.91. What is the ratio of the Amount of CO2 emissions(kg per 2005 US$ of GDP) of Palau in 2003 to that in 2005?
Your answer should be very brief. 1.1. What is the ratio of the Amount of CO2 emissions(kg per 2005 US$ of GDP) in West Bank and Gaza in 2003 to that in 2005?
Offer a very short reply. 0.56. What is the ratio of the Amount of CO2 emissions(kg per 2005 US$ of GDP) of Greenland in 2004 to that in 2005?
Your answer should be compact. 0.98. What is the ratio of the Amount of CO2 emissions(kg per 2005 US$ of GDP) in West Bank and Gaza in 2004 to that in 2005?
Give a very brief answer. 0.76. What is the difference between the highest and the second highest Amount of CO2 emissions(kg per 2005 US$ of GDP) in Palau?
Give a very brief answer. 0.02. What is the difference between the highest and the second highest Amount of CO2 emissions(kg per 2005 US$ of GDP) of West Bank and Gaza?
Your response must be concise. 0.14. What is the difference between the highest and the lowest Amount of CO2 emissions(kg per 2005 US$ of GDP) of Greenland?
Keep it short and to the point. 0.03. What is the difference between the highest and the lowest Amount of CO2 emissions(kg per 2005 US$ of GDP) of Palau?
Provide a succinct answer. 0.44. What is the difference between the highest and the lowest Amount of CO2 emissions(kg per 2005 US$ of GDP) in West Bank and Gaza?
Offer a terse response. 0.42. 